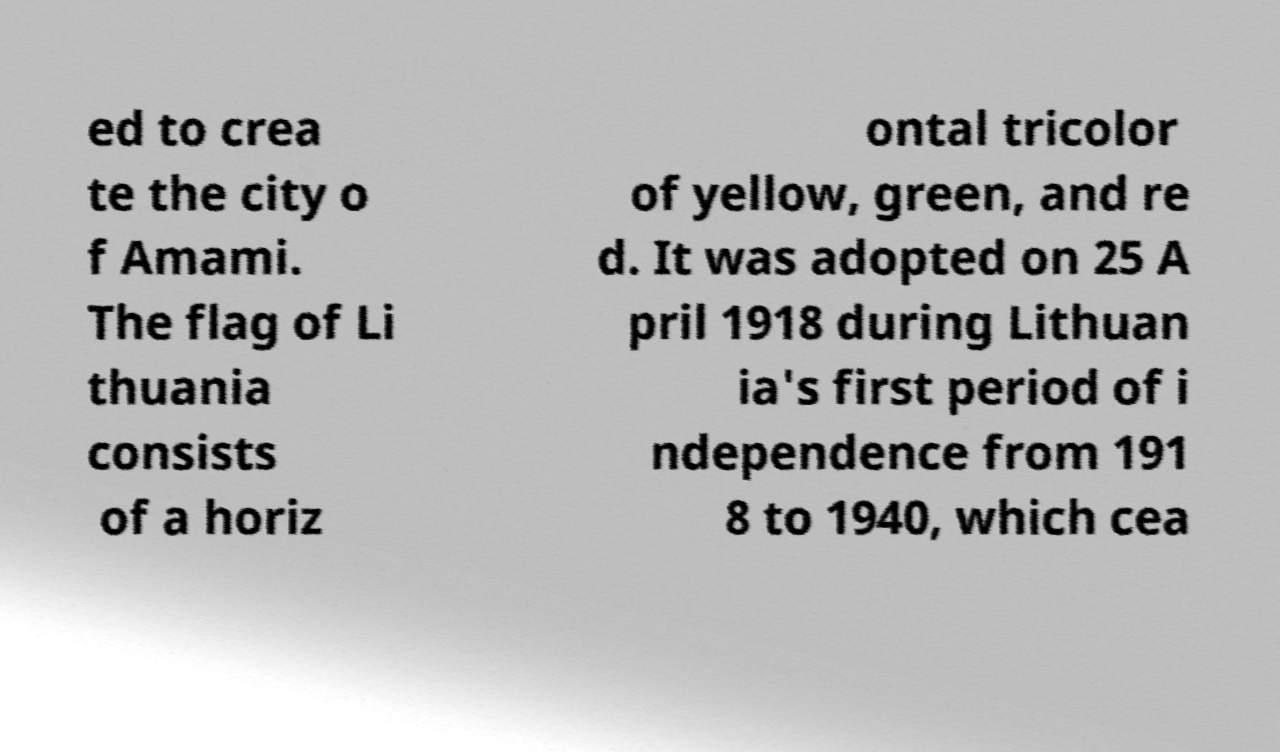I need the written content from this picture converted into text. Can you do that? ed to crea te the city o f Amami. The flag of Li thuania consists of a horiz ontal tricolor of yellow, green, and re d. It was adopted on 25 A pril 1918 during Lithuan ia's first period of i ndependence from 191 8 to 1940, which cea 